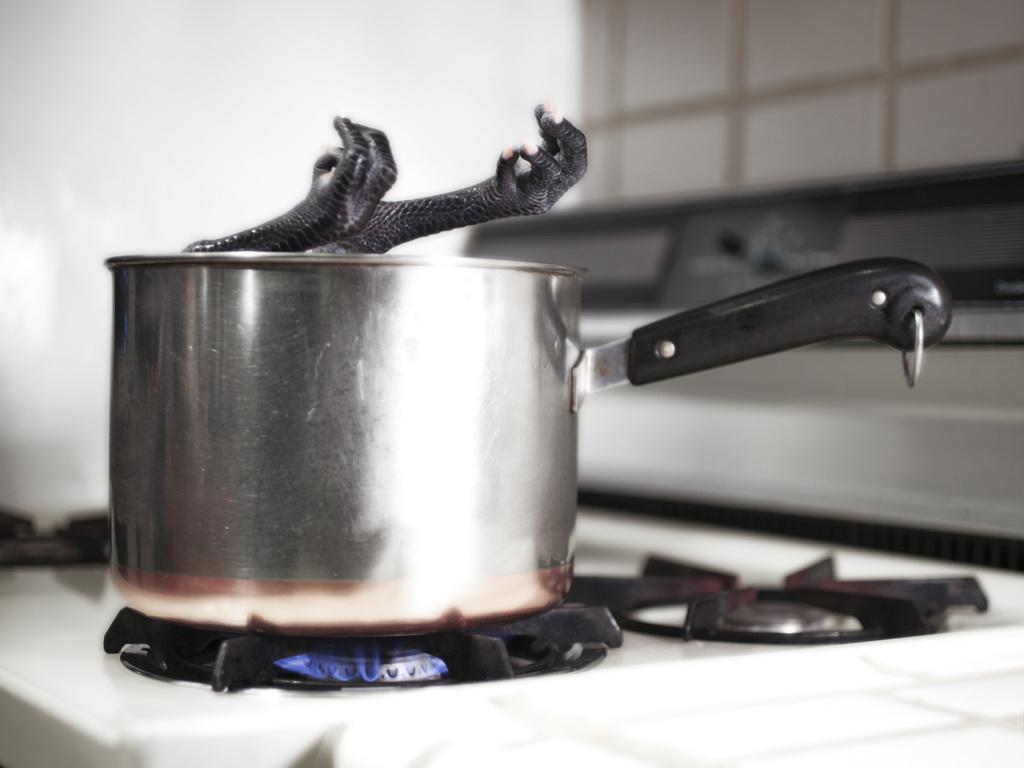Can you describe this image briefly? In the picture I can see a sauce pan which is placed on the stove and there is an object placed in it and there are some other objects in the background. 